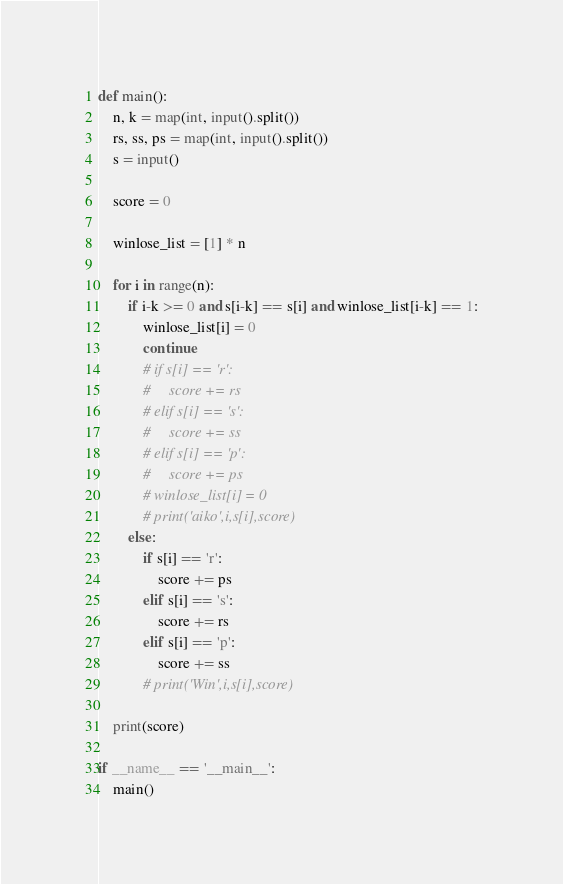<code> <loc_0><loc_0><loc_500><loc_500><_Python_>def main():
    n, k = map(int, input().split())
    rs, ss, ps = map(int, input().split())
    s = input()

    score = 0

    winlose_list = [1] * n

    for i in range(n):
        if i-k >= 0 and s[i-k] == s[i] and winlose_list[i-k] == 1:
            winlose_list[i] = 0
            continue
            # if s[i] == 'r':
            #     score += rs
            # elif s[i] == 's':
            #     score += ss
            # elif s[i] == 'p':
            #     score += ps
            # winlose_list[i] = 0
            # print('aiko',i,s[i],score)
        else:
            if s[i] == 'r':
                score += ps
            elif s[i] == 's':
                score += rs
            elif s[i] == 'p':
                score += ss
            # print('Win',i,s[i],score)
            
    print(score)

if __name__ == '__main__':
    main()</code> 